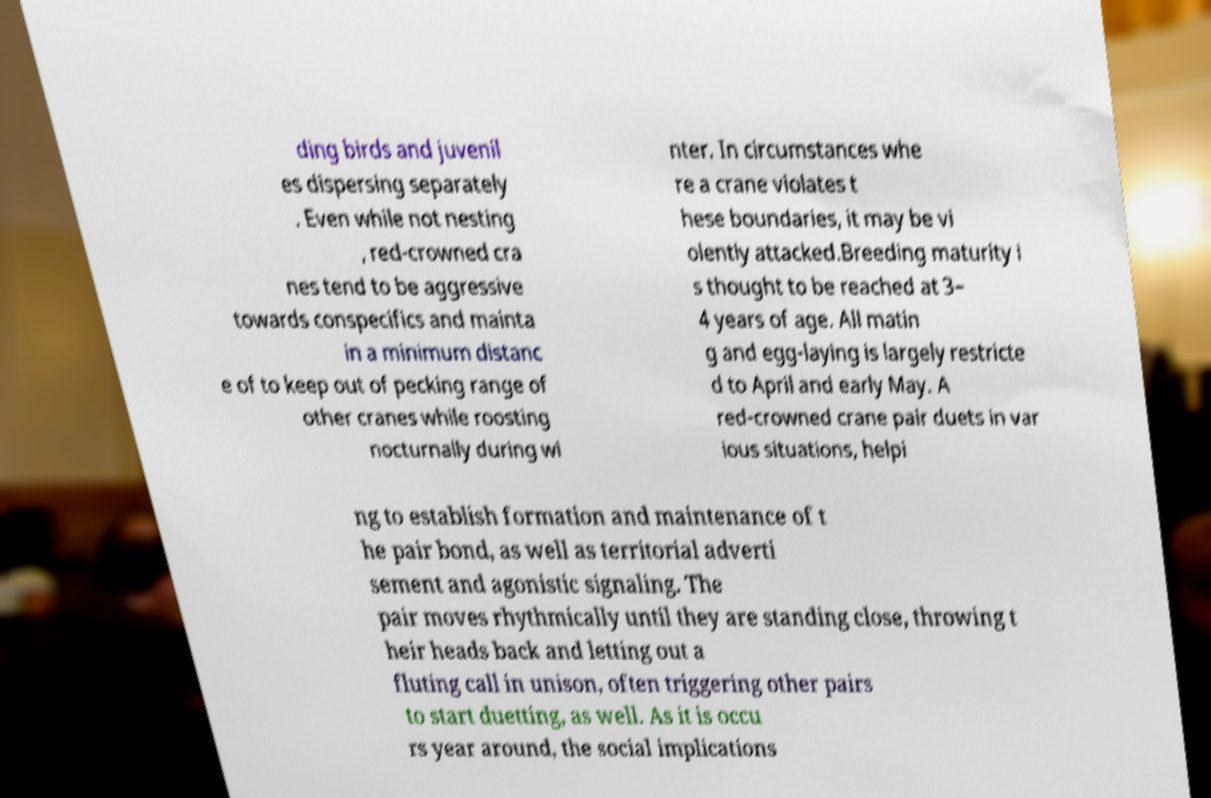Could you assist in decoding the text presented in this image and type it out clearly? ding birds and juvenil es dispersing separately . Even while not nesting , red-crowned cra nes tend to be aggressive towards conspecifics and mainta in a minimum distanc e of to keep out of pecking range of other cranes while roosting nocturnally during wi nter. In circumstances whe re a crane violates t hese boundaries, it may be vi olently attacked.Breeding maturity i s thought to be reached at 3– 4 years of age. All matin g and egg-laying is largely restricte d to April and early May. A red-crowned crane pair duets in var ious situations, helpi ng to establish formation and maintenance of t he pair bond, as well as territorial adverti sement and agonistic signaling. The pair moves rhythmically until they are standing close, throwing t heir heads back and letting out a fluting call in unison, often triggering other pairs to start duetting, as well. As it is occu rs year around, the social implications 